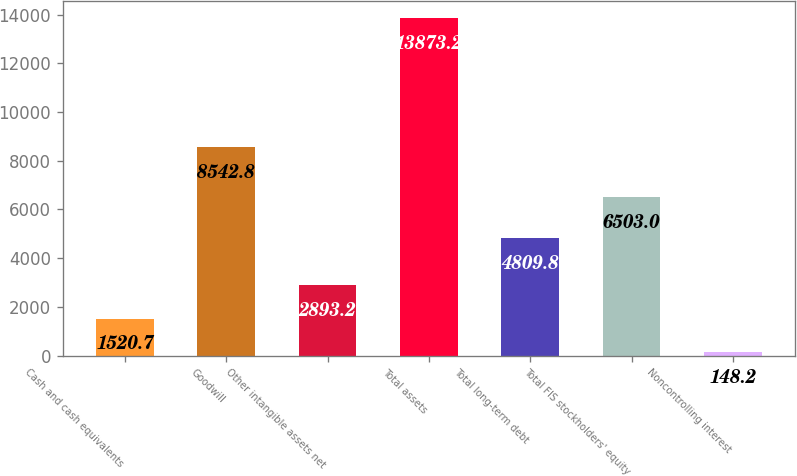Convert chart. <chart><loc_0><loc_0><loc_500><loc_500><bar_chart><fcel>Cash and cash equivalents<fcel>Goodwill<fcel>Other intangible assets net<fcel>Total assets<fcel>Total long-term debt<fcel>Total FIS stockholders' equity<fcel>Noncontrolling interest<nl><fcel>1520.7<fcel>8542.8<fcel>2893.2<fcel>13873.2<fcel>4809.8<fcel>6503<fcel>148.2<nl></chart> 